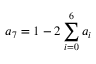Convert formula to latex. <formula><loc_0><loc_0><loc_500><loc_500>a _ { 7 } = 1 - 2 \sum _ { i = 0 } ^ { 6 } a _ { i }</formula> 